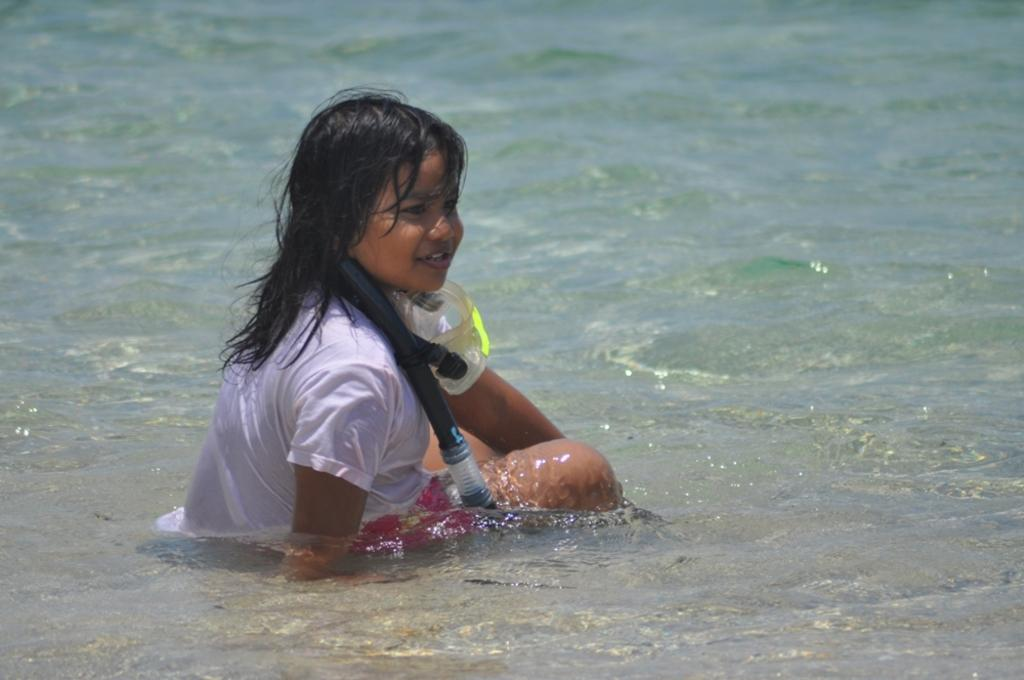What is the main subject of the image? The main subject of the image is a kid. Where is the kid located in the image? The kid is in the center of the image. What is the kid wearing in the image? The kid is wearing an oxygen mask. What can be seen at the bottom of the image? There is water visible at the bottom of the image. What type of chin can be seen on the cart in the image? There is no cart present in the image, and therefore no chin can be seen on it. 